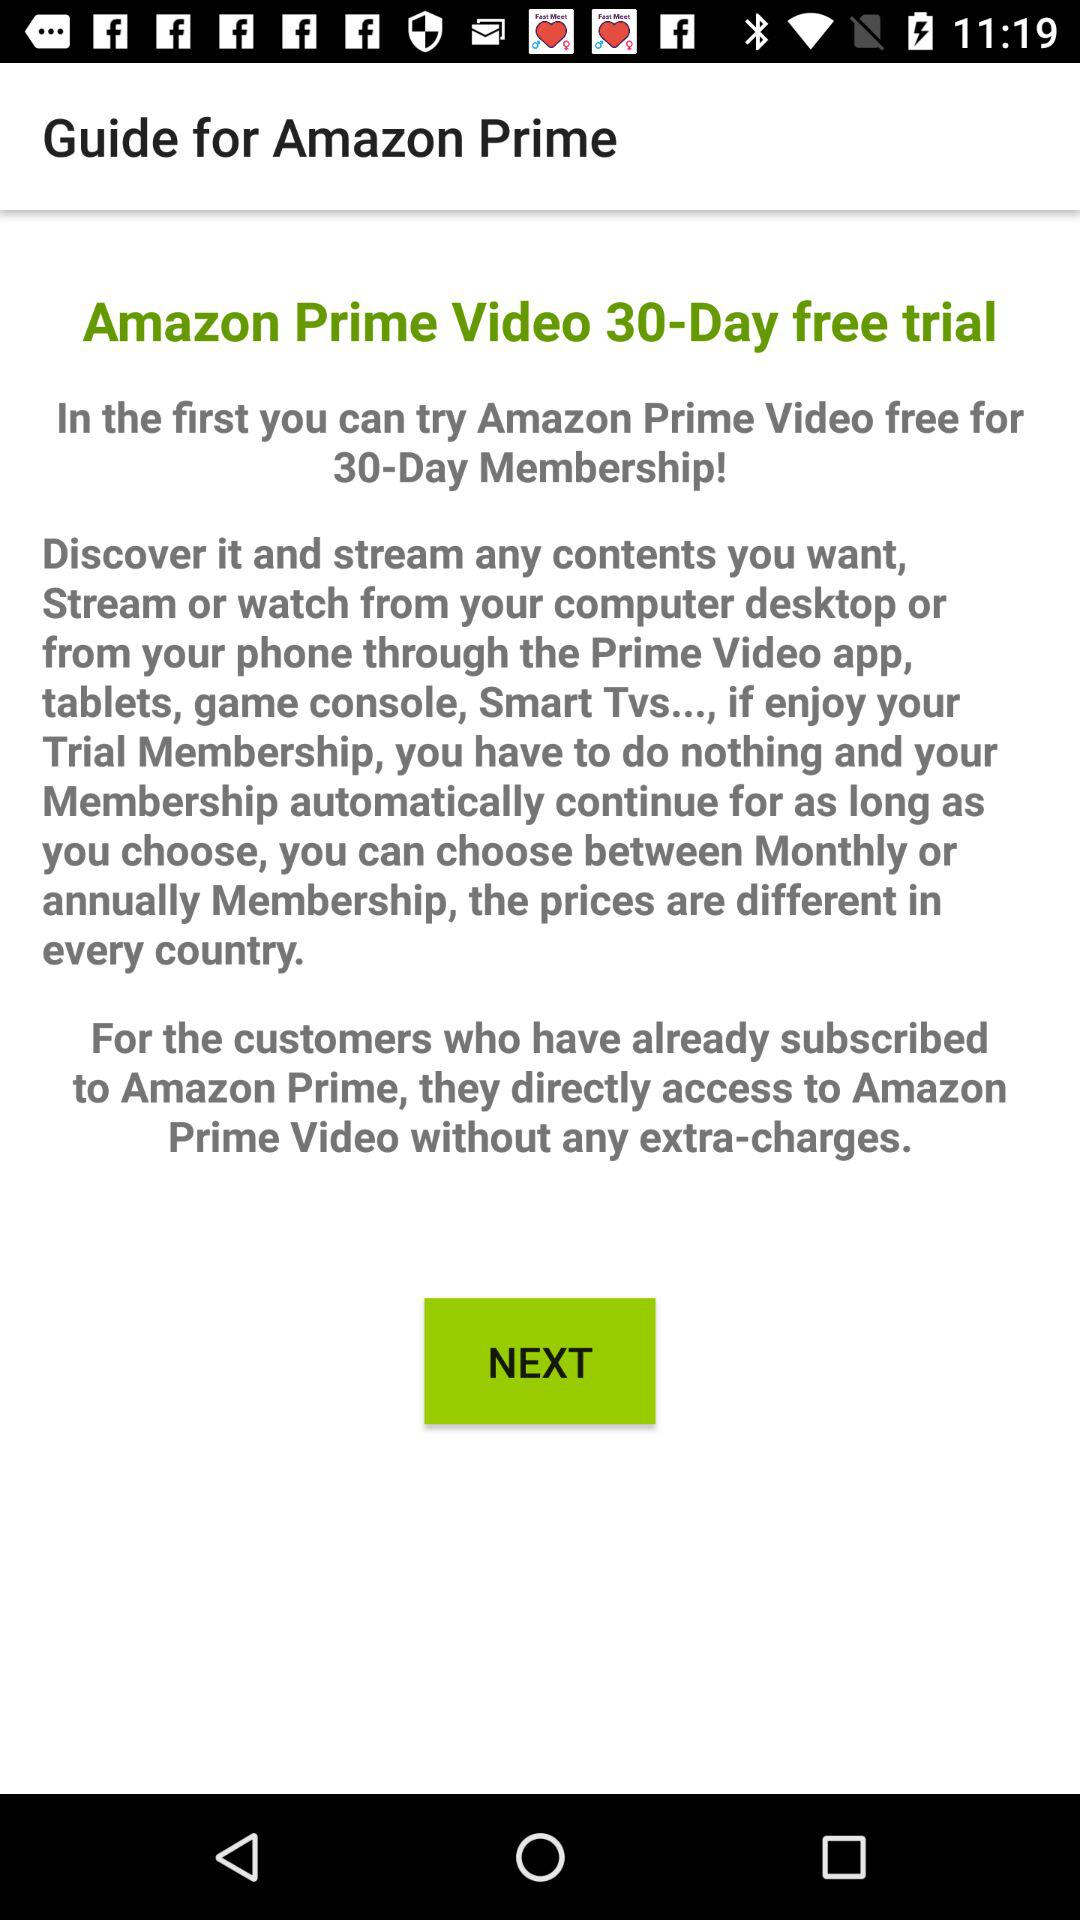For how many days is the trial free? The trial is free for 30 days. 